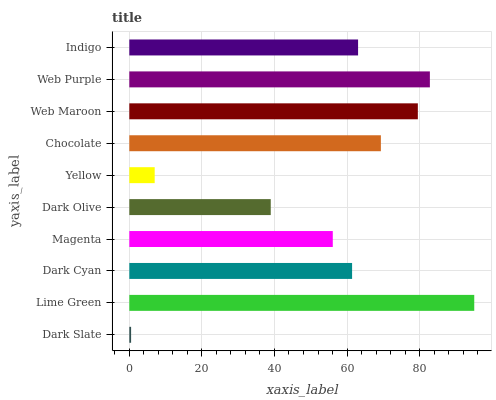Is Dark Slate the minimum?
Answer yes or no. Yes. Is Lime Green the maximum?
Answer yes or no. Yes. Is Dark Cyan the minimum?
Answer yes or no. No. Is Dark Cyan the maximum?
Answer yes or no. No. Is Lime Green greater than Dark Cyan?
Answer yes or no. Yes. Is Dark Cyan less than Lime Green?
Answer yes or no. Yes. Is Dark Cyan greater than Lime Green?
Answer yes or no. No. Is Lime Green less than Dark Cyan?
Answer yes or no. No. Is Indigo the high median?
Answer yes or no. Yes. Is Dark Cyan the low median?
Answer yes or no. Yes. Is Web Purple the high median?
Answer yes or no. No. Is Web Purple the low median?
Answer yes or no. No. 